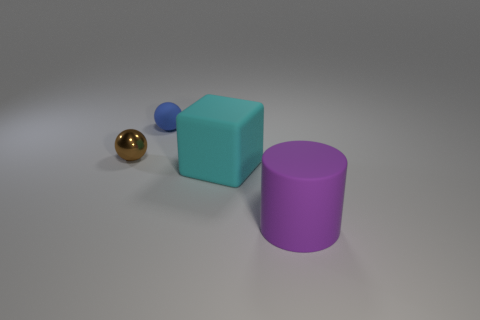Add 2 tiny brown metal spheres. How many objects exist? 6 Subtract all cylinders. How many objects are left? 3 Subtract 0 green cylinders. How many objects are left? 4 Subtract all blocks. Subtract all large blocks. How many objects are left? 2 Add 3 balls. How many balls are left? 5 Add 4 small brown objects. How many small brown objects exist? 5 